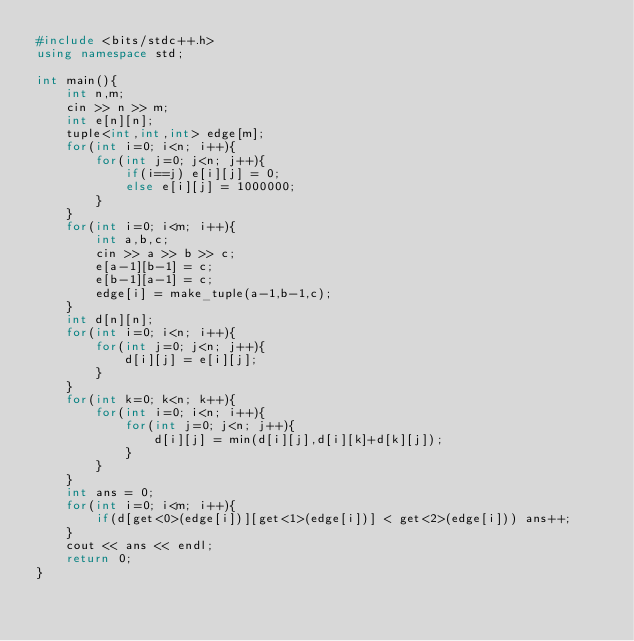Convert code to text. <code><loc_0><loc_0><loc_500><loc_500><_C++_>#include <bits/stdc++.h>
using namespace std;

int main(){
    int n,m;
    cin >> n >> m;
    int e[n][n];
    tuple<int,int,int> edge[m];
    for(int i=0; i<n; i++){
        for(int j=0; j<n; j++){
            if(i==j) e[i][j] = 0;
            else e[i][j] = 1000000;
        }
    }
    for(int i=0; i<m; i++){
        int a,b,c;
        cin >> a >> b >> c;
        e[a-1][b-1] = c;
        e[b-1][a-1] = c;
        edge[i] = make_tuple(a-1,b-1,c);
    }
    int d[n][n];
    for(int i=0; i<n; i++){
        for(int j=0; j<n; j++){
            d[i][j] = e[i][j];
        }
    }
    for(int k=0; k<n; k++){
        for(int i=0; i<n; i++){
            for(int j=0; j<n; j++){
                d[i][j] = min(d[i][j],d[i][k]+d[k][j]);
            }
        }
    }
    int ans = 0;
    for(int i=0; i<m; i++){
        if(d[get<0>(edge[i])][get<1>(edge[i])] < get<2>(edge[i])) ans++;
    }
    cout << ans << endl;
    return 0;
}
</code> 